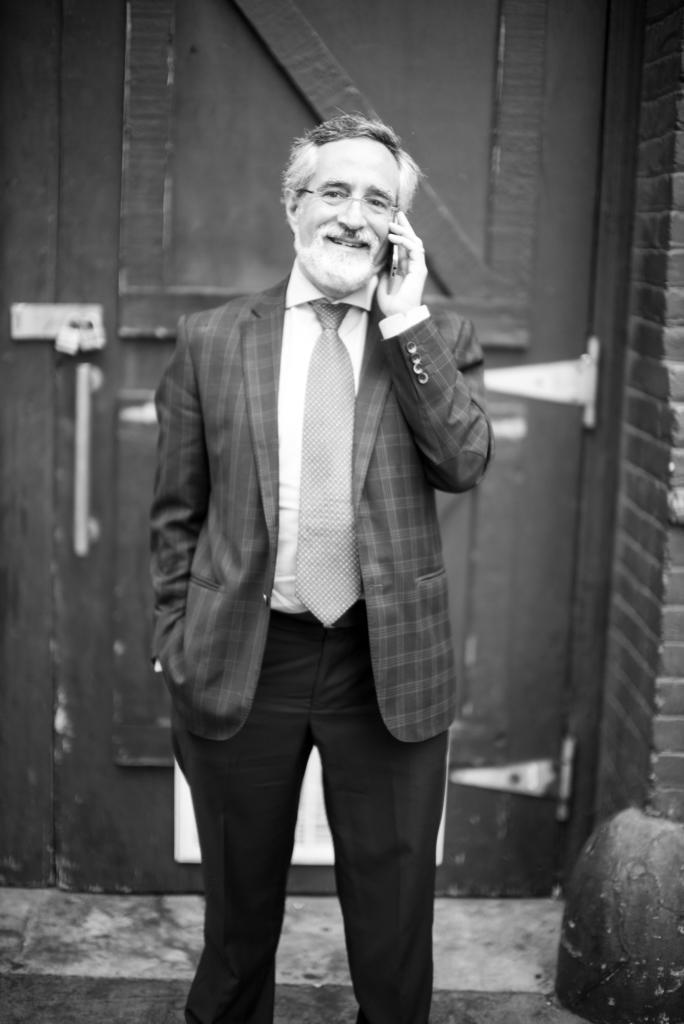Can you describe this image briefly? In this image there is a person standing and he is holding an object in the foreground. There is a wall on the left corner. There is floor at the bottom. There is an object that looks like a door in the background. 